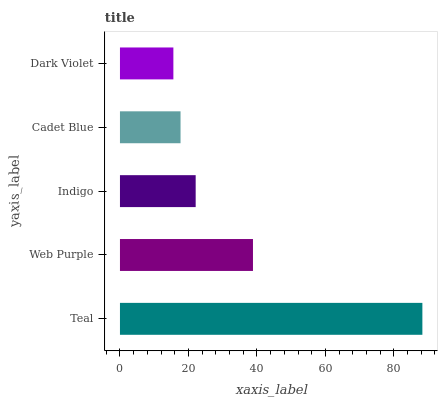Is Dark Violet the minimum?
Answer yes or no. Yes. Is Teal the maximum?
Answer yes or no. Yes. Is Web Purple the minimum?
Answer yes or no. No. Is Web Purple the maximum?
Answer yes or no. No. Is Teal greater than Web Purple?
Answer yes or no. Yes. Is Web Purple less than Teal?
Answer yes or no. Yes. Is Web Purple greater than Teal?
Answer yes or no. No. Is Teal less than Web Purple?
Answer yes or no. No. Is Indigo the high median?
Answer yes or no. Yes. Is Indigo the low median?
Answer yes or no. Yes. Is Dark Violet the high median?
Answer yes or no. No. Is Dark Violet the low median?
Answer yes or no. No. 